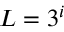Convert formula to latex. <formula><loc_0><loc_0><loc_500><loc_500>L = 3 ^ { i }</formula> 